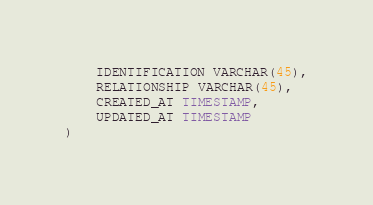<code> <loc_0><loc_0><loc_500><loc_500><_SQL_>    IDENTIFICATION VARCHAR(45),
    RELATIONSHIP VARCHAR(45),
    CREATED_AT TIMESTAMP,
    UPDATED_AT TIMESTAMP
)
</code> 